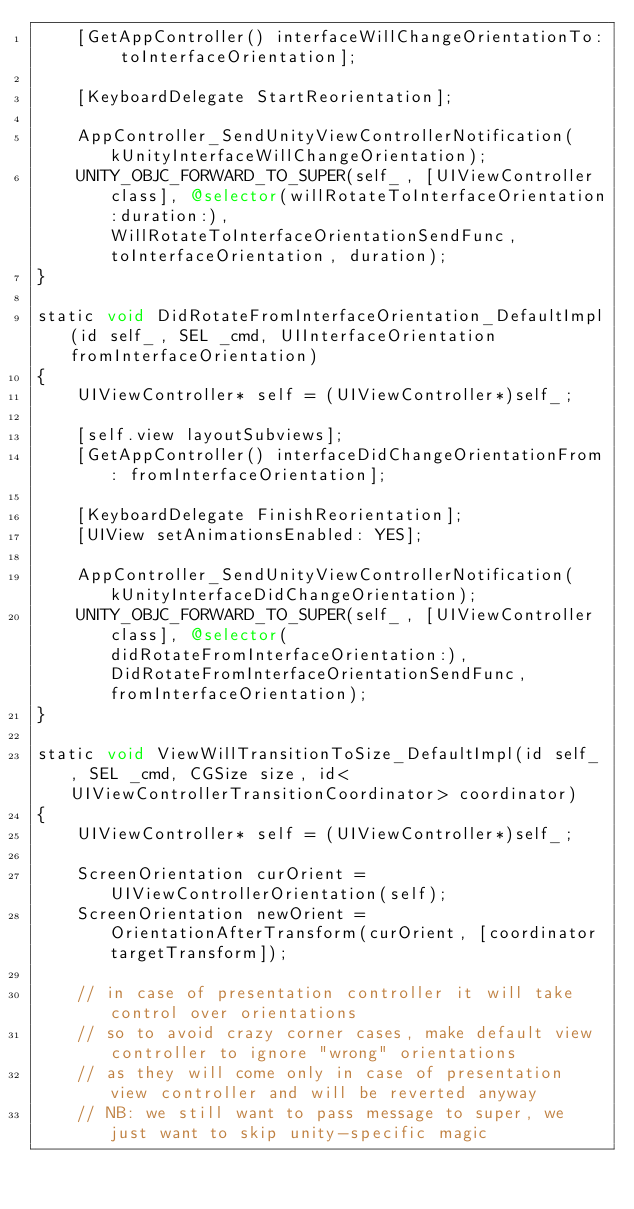<code> <loc_0><loc_0><loc_500><loc_500><_ObjectiveC_>    [GetAppController() interfaceWillChangeOrientationTo: toInterfaceOrientation];

    [KeyboardDelegate StartReorientation];

    AppController_SendUnityViewControllerNotification(kUnityInterfaceWillChangeOrientation);
    UNITY_OBJC_FORWARD_TO_SUPER(self_, [UIViewController class], @selector(willRotateToInterfaceOrientation:duration:), WillRotateToInterfaceOrientationSendFunc, toInterfaceOrientation, duration);
}

static void DidRotateFromInterfaceOrientation_DefaultImpl(id self_, SEL _cmd, UIInterfaceOrientation fromInterfaceOrientation)
{
    UIViewController* self = (UIViewController*)self_;

    [self.view layoutSubviews];
    [GetAppController() interfaceDidChangeOrientationFrom: fromInterfaceOrientation];

    [KeyboardDelegate FinishReorientation];
    [UIView setAnimationsEnabled: YES];

    AppController_SendUnityViewControllerNotification(kUnityInterfaceDidChangeOrientation);
    UNITY_OBJC_FORWARD_TO_SUPER(self_, [UIViewController class], @selector(didRotateFromInterfaceOrientation:), DidRotateFromInterfaceOrientationSendFunc, fromInterfaceOrientation);
}

static void ViewWillTransitionToSize_DefaultImpl(id self_, SEL _cmd, CGSize size, id<UIViewControllerTransitionCoordinator> coordinator)
{
    UIViewController* self = (UIViewController*)self_;

    ScreenOrientation curOrient = UIViewControllerOrientation(self);
    ScreenOrientation newOrient = OrientationAfterTransform(curOrient, [coordinator targetTransform]);

    // in case of presentation controller it will take control over orientations
    // so to avoid crazy corner cases, make default view controller to ignore "wrong" orientations
    // as they will come only in case of presentation view controller and will be reverted anyway
    // NB: we still want to pass message to super, we just want to skip unity-specific magic</code> 